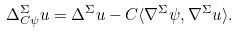Convert formula to latex. <formula><loc_0><loc_0><loc_500><loc_500>\Delta _ { C \psi } ^ { \Sigma } u = \Delta ^ { \Sigma } u - C \langle \nabla ^ { \Sigma } \psi , \nabla ^ { \Sigma } u \rangle .</formula> 